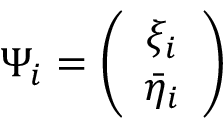<formula> <loc_0><loc_0><loc_500><loc_500>\Psi _ { i } = \left ( \begin{array} { c } { { \xi _ { i } } } \\ { { \bar { \eta } _ { i } } } \end{array} \right )</formula> 